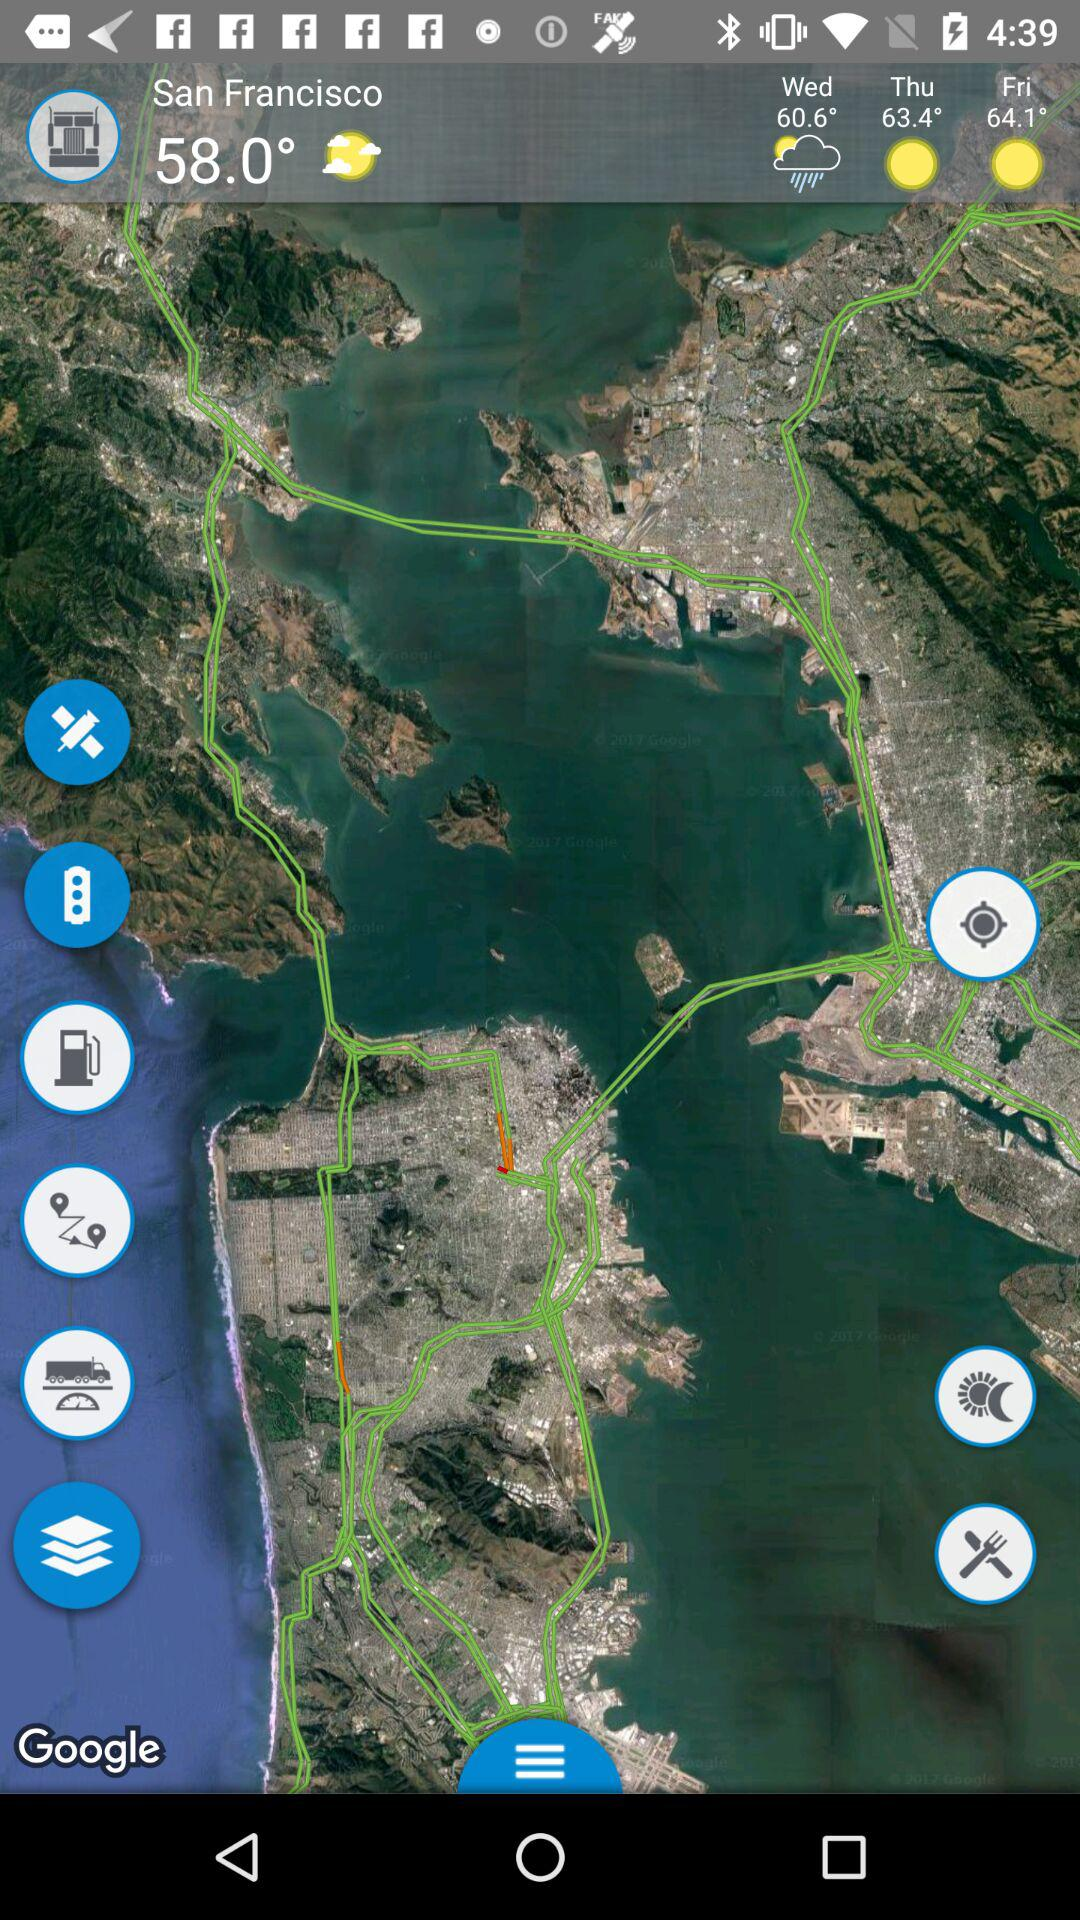What is the location? The location is San Francisco. 